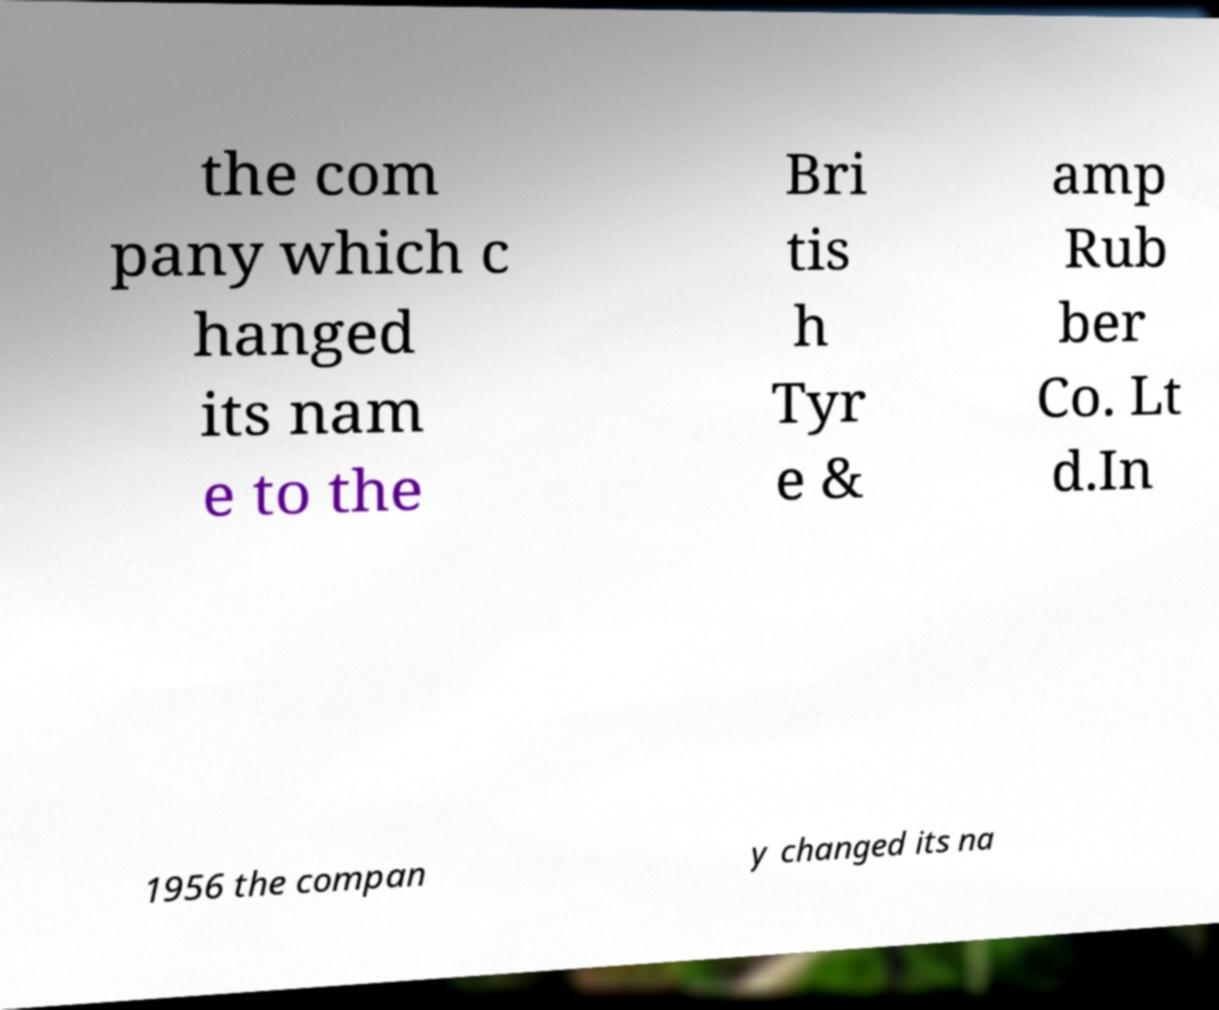I need the written content from this picture converted into text. Can you do that? the com pany which c hanged its nam e to the Bri tis h Tyr e & amp Rub ber Co. Lt d.In 1956 the compan y changed its na 